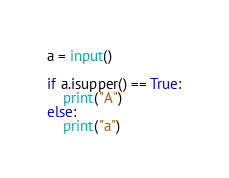<code> <loc_0><loc_0><loc_500><loc_500><_Python_>a = input()

if a.isupper() == True:
    print("A")
else:
    print("a")</code> 